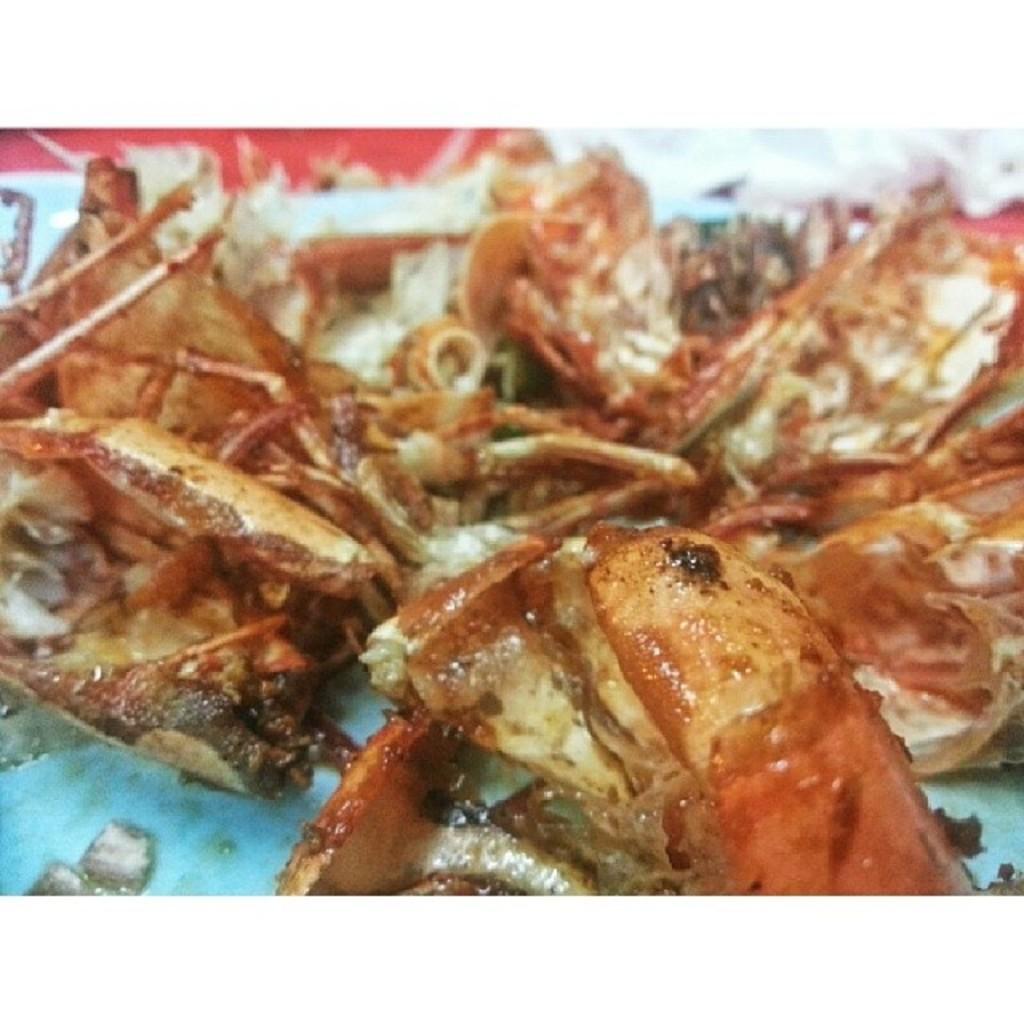Describe this image in one or two sentences. This is a zoomed in picture. In the center we can see the food items placed on the surface of an object. 